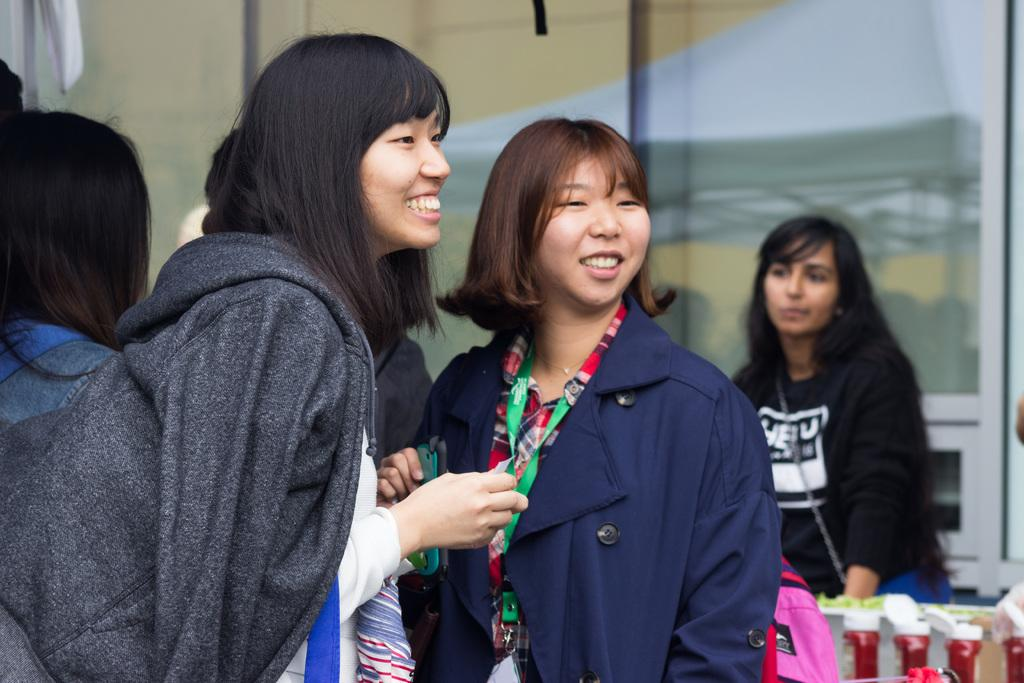What is the main subject of the image? The main subject of the image is the women in the center. What is the facial expression of the women? The women are smiling. What can be seen in the background of the image? There are people and a wall in the background of the image. What type of cabbage is being processed by the tree in the image? There is no cabbage or tree present in the image. 